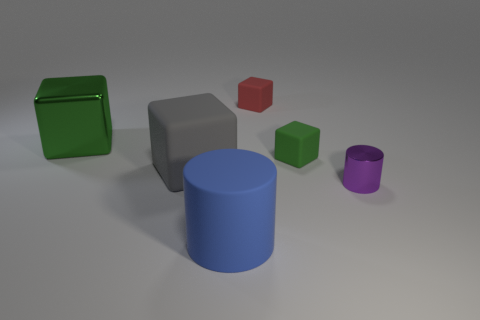The green matte object that is the same shape as the small red thing is what size?
Keep it short and to the point. Small. What number of things are either big cylinders that are on the left side of the purple metallic cylinder or big blue cylinders that are to the right of the big green shiny object?
Keep it short and to the point. 1. Is the number of large matte cubes less than the number of matte blocks?
Give a very brief answer. Yes. There is a purple metallic thing; is its size the same as the cylinder that is on the left side of the small purple cylinder?
Give a very brief answer. No. What number of matte things are large objects or gray things?
Your answer should be compact. 2. Are there more large green cubes than brown matte balls?
Provide a short and direct response. Yes. There is a thing that is the same color as the big metallic block; what size is it?
Provide a succinct answer. Small. What shape is the metal object that is behind the matte cube left of the big blue thing?
Give a very brief answer. Cube. There is a green object on the right side of the big matte thing on the left side of the big blue rubber cylinder; is there a cube that is in front of it?
Provide a short and direct response. Yes. There is a shiny cube that is the same size as the gray thing; what is its color?
Keep it short and to the point. Green. 